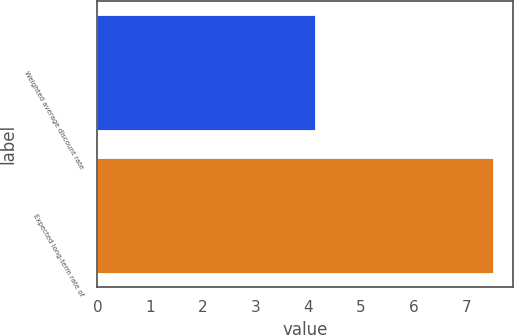Convert chart. <chart><loc_0><loc_0><loc_500><loc_500><bar_chart><fcel>Weighted average discount rate<fcel>Expected long-term rate of<nl><fcel>4.12<fcel>7.5<nl></chart> 